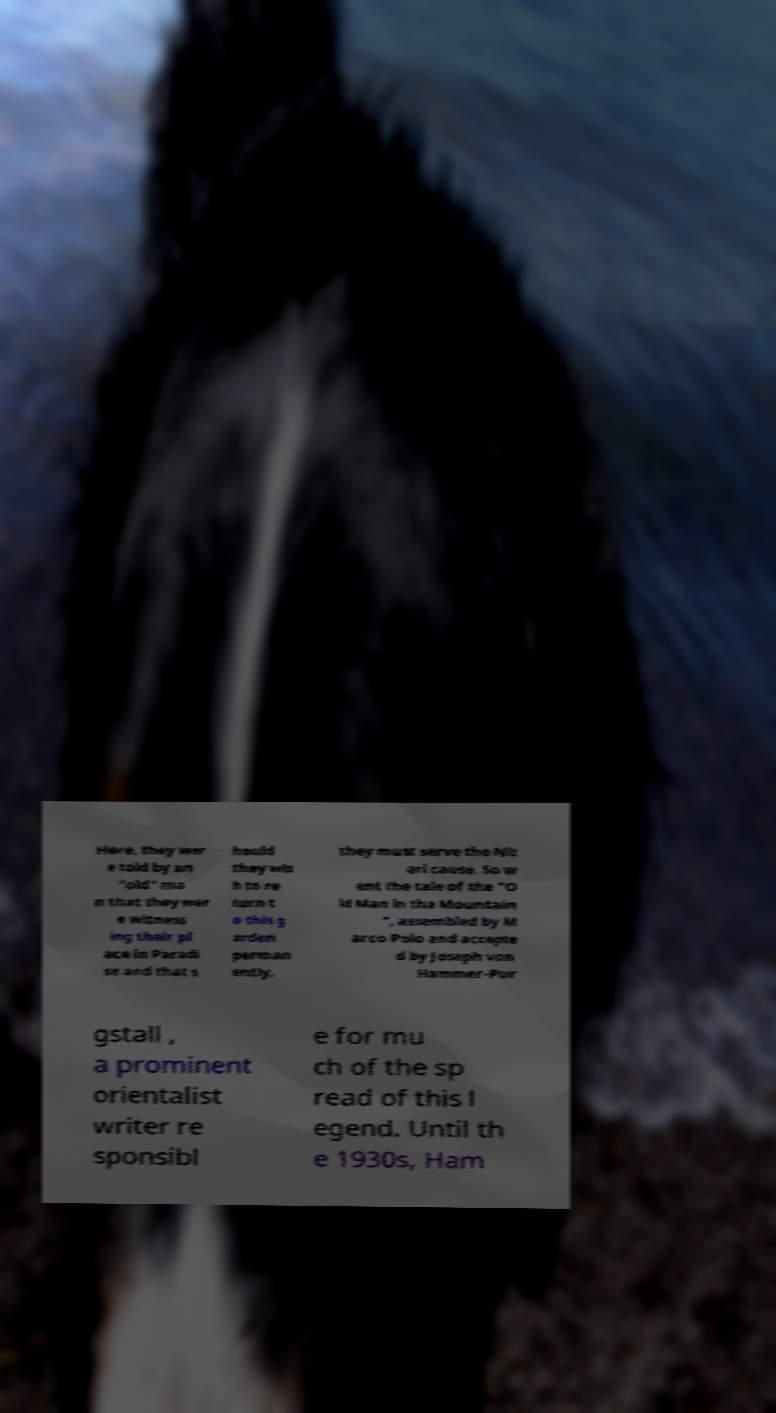There's text embedded in this image that I need extracted. Can you transcribe it verbatim? Here, they wer e told by an "old" ma n that they wer e witness ing their pl ace in Paradi se and that s hould they wis h to re turn t o this g arden perman ently, they must serve the Niz ari cause. So w ent the tale of the "O ld Man in the Mountain ", assembled by M arco Polo and accepte d by Joseph von Hammer-Pur gstall , a prominent orientalist writer re sponsibl e for mu ch of the sp read of this l egend. Until th e 1930s, Ham 